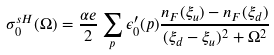Convert formula to latex. <formula><loc_0><loc_0><loc_500><loc_500>\sigma _ { 0 } ^ { s H } ( \Omega ) = \frac { \alpha e } { 2 } \sum _ { p } \epsilon ^ { \prime } _ { 0 } ( p ) \frac { n _ { F } ( \xi _ { u } ) - n _ { F } ( \xi _ { d } ) } { ( \xi _ { d } - \xi _ { u } ) ^ { 2 } + \Omega ^ { 2 } }</formula> 